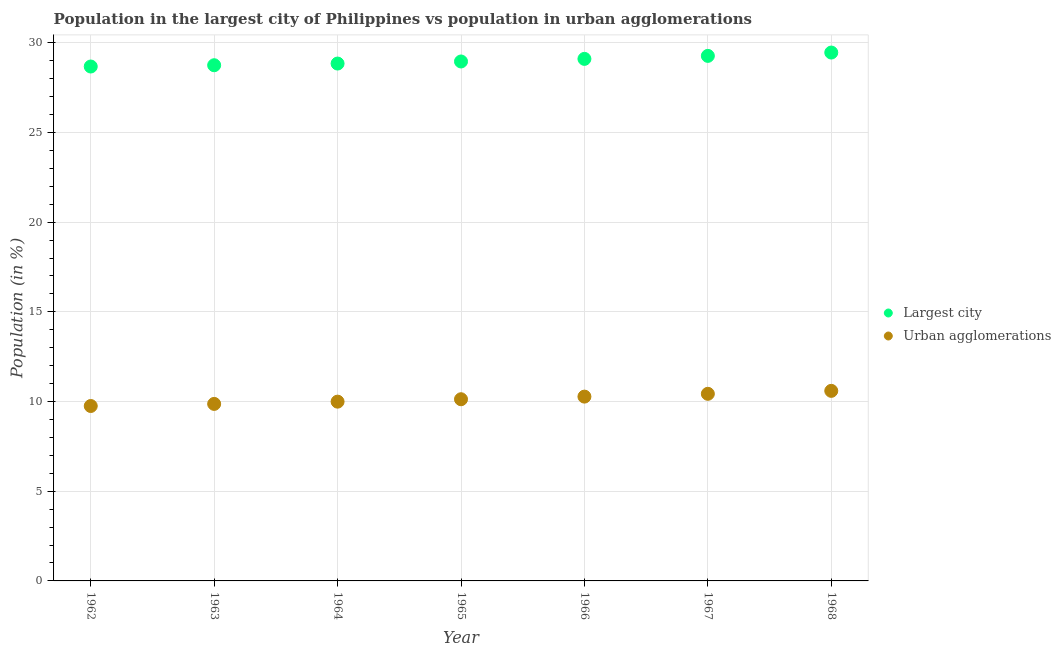How many different coloured dotlines are there?
Make the answer very short. 2. Is the number of dotlines equal to the number of legend labels?
Provide a short and direct response. Yes. What is the population in urban agglomerations in 1967?
Give a very brief answer. 10.43. Across all years, what is the maximum population in the largest city?
Give a very brief answer. 29.45. Across all years, what is the minimum population in the largest city?
Provide a short and direct response. 28.67. In which year was the population in the largest city maximum?
Ensure brevity in your answer.  1968. What is the total population in the largest city in the graph?
Provide a short and direct response. 203.03. What is the difference between the population in urban agglomerations in 1962 and that in 1968?
Offer a terse response. -0.84. What is the difference between the population in the largest city in 1966 and the population in urban agglomerations in 1963?
Provide a short and direct response. 19.23. What is the average population in urban agglomerations per year?
Ensure brevity in your answer.  10.15. In the year 1964, what is the difference between the population in urban agglomerations and population in the largest city?
Ensure brevity in your answer.  -18.85. What is the ratio of the population in urban agglomerations in 1964 to that in 1967?
Give a very brief answer. 0.96. Is the population in the largest city in 1965 less than that in 1967?
Keep it short and to the point. Yes. Is the difference between the population in the largest city in 1965 and 1967 greater than the difference between the population in urban agglomerations in 1965 and 1967?
Your response must be concise. No. What is the difference between the highest and the second highest population in urban agglomerations?
Provide a succinct answer. 0.16. What is the difference between the highest and the lowest population in the largest city?
Your answer should be very brief. 0.78. Does the population in the largest city monotonically increase over the years?
Make the answer very short. Yes. Is the population in urban agglomerations strictly greater than the population in the largest city over the years?
Offer a very short reply. No. Is the population in urban agglomerations strictly less than the population in the largest city over the years?
Provide a short and direct response. Yes. How many dotlines are there?
Provide a succinct answer. 2. How many years are there in the graph?
Ensure brevity in your answer.  7. Are the values on the major ticks of Y-axis written in scientific E-notation?
Your response must be concise. No. Where does the legend appear in the graph?
Your answer should be very brief. Center right. How many legend labels are there?
Offer a terse response. 2. How are the legend labels stacked?
Make the answer very short. Vertical. What is the title of the graph?
Offer a very short reply. Population in the largest city of Philippines vs population in urban agglomerations. What is the label or title of the X-axis?
Offer a terse response. Year. What is the label or title of the Y-axis?
Ensure brevity in your answer.  Population (in %). What is the Population (in %) of Largest city in 1962?
Offer a very short reply. 28.67. What is the Population (in %) in Urban agglomerations in 1962?
Your response must be concise. 9.75. What is the Population (in %) in Largest city in 1963?
Provide a succinct answer. 28.75. What is the Population (in %) in Urban agglomerations in 1963?
Make the answer very short. 9.87. What is the Population (in %) in Largest city in 1964?
Keep it short and to the point. 28.84. What is the Population (in %) in Urban agglomerations in 1964?
Your answer should be compact. 9.99. What is the Population (in %) in Largest city in 1965?
Your answer should be very brief. 28.95. What is the Population (in %) in Urban agglomerations in 1965?
Your response must be concise. 10.13. What is the Population (in %) in Largest city in 1966?
Provide a short and direct response. 29.1. What is the Population (in %) in Urban agglomerations in 1966?
Your response must be concise. 10.27. What is the Population (in %) of Largest city in 1967?
Give a very brief answer. 29.27. What is the Population (in %) in Urban agglomerations in 1967?
Make the answer very short. 10.43. What is the Population (in %) of Largest city in 1968?
Make the answer very short. 29.45. What is the Population (in %) in Urban agglomerations in 1968?
Keep it short and to the point. 10.59. Across all years, what is the maximum Population (in %) in Largest city?
Offer a very short reply. 29.45. Across all years, what is the maximum Population (in %) of Urban agglomerations?
Provide a short and direct response. 10.59. Across all years, what is the minimum Population (in %) of Largest city?
Offer a very short reply. 28.67. Across all years, what is the minimum Population (in %) of Urban agglomerations?
Your response must be concise. 9.75. What is the total Population (in %) of Largest city in the graph?
Offer a very short reply. 203.03. What is the total Population (in %) of Urban agglomerations in the graph?
Give a very brief answer. 71.03. What is the difference between the Population (in %) of Largest city in 1962 and that in 1963?
Your answer should be compact. -0.07. What is the difference between the Population (in %) of Urban agglomerations in 1962 and that in 1963?
Provide a short and direct response. -0.12. What is the difference between the Population (in %) in Largest city in 1962 and that in 1964?
Your answer should be compact. -0.17. What is the difference between the Population (in %) of Urban agglomerations in 1962 and that in 1964?
Offer a terse response. -0.24. What is the difference between the Population (in %) in Largest city in 1962 and that in 1965?
Provide a succinct answer. -0.28. What is the difference between the Population (in %) in Urban agglomerations in 1962 and that in 1965?
Give a very brief answer. -0.38. What is the difference between the Population (in %) in Largest city in 1962 and that in 1966?
Make the answer very short. -0.43. What is the difference between the Population (in %) in Urban agglomerations in 1962 and that in 1966?
Provide a short and direct response. -0.52. What is the difference between the Population (in %) in Largest city in 1962 and that in 1967?
Offer a terse response. -0.59. What is the difference between the Population (in %) of Urban agglomerations in 1962 and that in 1967?
Provide a short and direct response. -0.68. What is the difference between the Population (in %) in Largest city in 1962 and that in 1968?
Offer a very short reply. -0.78. What is the difference between the Population (in %) in Urban agglomerations in 1962 and that in 1968?
Ensure brevity in your answer.  -0.84. What is the difference between the Population (in %) in Largest city in 1963 and that in 1964?
Provide a short and direct response. -0.09. What is the difference between the Population (in %) of Urban agglomerations in 1963 and that in 1964?
Keep it short and to the point. -0.13. What is the difference between the Population (in %) of Largest city in 1963 and that in 1965?
Your answer should be compact. -0.21. What is the difference between the Population (in %) of Urban agglomerations in 1963 and that in 1965?
Your answer should be very brief. -0.26. What is the difference between the Population (in %) of Largest city in 1963 and that in 1966?
Make the answer very short. -0.35. What is the difference between the Population (in %) in Urban agglomerations in 1963 and that in 1966?
Ensure brevity in your answer.  -0.41. What is the difference between the Population (in %) in Largest city in 1963 and that in 1967?
Your answer should be very brief. -0.52. What is the difference between the Population (in %) of Urban agglomerations in 1963 and that in 1967?
Your response must be concise. -0.56. What is the difference between the Population (in %) of Largest city in 1963 and that in 1968?
Your answer should be compact. -0.71. What is the difference between the Population (in %) of Urban agglomerations in 1963 and that in 1968?
Your answer should be very brief. -0.73. What is the difference between the Population (in %) in Largest city in 1964 and that in 1965?
Offer a terse response. -0.12. What is the difference between the Population (in %) in Urban agglomerations in 1964 and that in 1965?
Keep it short and to the point. -0.13. What is the difference between the Population (in %) in Largest city in 1964 and that in 1966?
Keep it short and to the point. -0.26. What is the difference between the Population (in %) in Urban agglomerations in 1964 and that in 1966?
Make the answer very short. -0.28. What is the difference between the Population (in %) in Largest city in 1964 and that in 1967?
Keep it short and to the point. -0.43. What is the difference between the Population (in %) in Urban agglomerations in 1964 and that in 1967?
Your response must be concise. -0.44. What is the difference between the Population (in %) of Largest city in 1964 and that in 1968?
Give a very brief answer. -0.61. What is the difference between the Population (in %) of Urban agglomerations in 1964 and that in 1968?
Keep it short and to the point. -0.6. What is the difference between the Population (in %) in Largest city in 1965 and that in 1966?
Keep it short and to the point. -0.14. What is the difference between the Population (in %) of Urban agglomerations in 1965 and that in 1966?
Offer a terse response. -0.15. What is the difference between the Population (in %) in Largest city in 1965 and that in 1967?
Provide a short and direct response. -0.31. What is the difference between the Population (in %) in Urban agglomerations in 1965 and that in 1967?
Provide a short and direct response. -0.3. What is the difference between the Population (in %) of Largest city in 1965 and that in 1968?
Offer a terse response. -0.5. What is the difference between the Population (in %) in Urban agglomerations in 1965 and that in 1968?
Make the answer very short. -0.47. What is the difference between the Population (in %) of Largest city in 1966 and that in 1967?
Your answer should be very brief. -0.17. What is the difference between the Population (in %) of Urban agglomerations in 1966 and that in 1967?
Provide a short and direct response. -0.16. What is the difference between the Population (in %) in Largest city in 1966 and that in 1968?
Make the answer very short. -0.35. What is the difference between the Population (in %) in Urban agglomerations in 1966 and that in 1968?
Ensure brevity in your answer.  -0.32. What is the difference between the Population (in %) in Largest city in 1967 and that in 1968?
Provide a succinct answer. -0.19. What is the difference between the Population (in %) of Urban agglomerations in 1967 and that in 1968?
Your response must be concise. -0.16. What is the difference between the Population (in %) in Largest city in 1962 and the Population (in %) in Urban agglomerations in 1963?
Make the answer very short. 18.81. What is the difference between the Population (in %) of Largest city in 1962 and the Population (in %) of Urban agglomerations in 1964?
Ensure brevity in your answer.  18.68. What is the difference between the Population (in %) in Largest city in 1962 and the Population (in %) in Urban agglomerations in 1965?
Offer a terse response. 18.55. What is the difference between the Population (in %) in Largest city in 1962 and the Population (in %) in Urban agglomerations in 1966?
Your response must be concise. 18.4. What is the difference between the Population (in %) in Largest city in 1962 and the Population (in %) in Urban agglomerations in 1967?
Provide a succinct answer. 18.24. What is the difference between the Population (in %) of Largest city in 1962 and the Population (in %) of Urban agglomerations in 1968?
Provide a succinct answer. 18.08. What is the difference between the Population (in %) of Largest city in 1963 and the Population (in %) of Urban agglomerations in 1964?
Your answer should be compact. 18.75. What is the difference between the Population (in %) of Largest city in 1963 and the Population (in %) of Urban agglomerations in 1965?
Provide a succinct answer. 18.62. What is the difference between the Population (in %) in Largest city in 1963 and the Population (in %) in Urban agglomerations in 1966?
Make the answer very short. 18.47. What is the difference between the Population (in %) in Largest city in 1963 and the Population (in %) in Urban agglomerations in 1967?
Give a very brief answer. 18.32. What is the difference between the Population (in %) in Largest city in 1963 and the Population (in %) in Urban agglomerations in 1968?
Provide a short and direct response. 18.15. What is the difference between the Population (in %) in Largest city in 1964 and the Population (in %) in Urban agglomerations in 1965?
Provide a succinct answer. 18.71. What is the difference between the Population (in %) of Largest city in 1964 and the Population (in %) of Urban agglomerations in 1966?
Keep it short and to the point. 18.57. What is the difference between the Population (in %) of Largest city in 1964 and the Population (in %) of Urban agglomerations in 1967?
Keep it short and to the point. 18.41. What is the difference between the Population (in %) of Largest city in 1964 and the Population (in %) of Urban agglomerations in 1968?
Your response must be concise. 18.24. What is the difference between the Population (in %) in Largest city in 1965 and the Population (in %) in Urban agglomerations in 1966?
Make the answer very short. 18.68. What is the difference between the Population (in %) of Largest city in 1965 and the Population (in %) of Urban agglomerations in 1967?
Offer a terse response. 18.52. What is the difference between the Population (in %) in Largest city in 1965 and the Population (in %) in Urban agglomerations in 1968?
Offer a terse response. 18.36. What is the difference between the Population (in %) of Largest city in 1966 and the Population (in %) of Urban agglomerations in 1967?
Offer a very short reply. 18.67. What is the difference between the Population (in %) in Largest city in 1966 and the Population (in %) in Urban agglomerations in 1968?
Provide a short and direct response. 18.5. What is the difference between the Population (in %) in Largest city in 1967 and the Population (in %) in Urban agglomerations in 1968?
Your response must be concise. 18.67. What is the average Population (in %) of Largest city per year?
Your response must be concise. 29. What is the average Population (in %) of Urban agglomerations per year?
Your answer should be very brief. 10.15. In the year 1962, what is the difference between the Population (in %) of Largest city and Population (in %) of Urban agglomerations?
Provide a succinct answer. 18.92. In the year 1963, what is the difference between the Population (in %) in Largest city and Population (in %) in Urban agglomerations?
Your response must be concise. 18.88. In the year 1964, what is the difference between the Population (in %) of Largest city and Population (in %) of Urban agglomerations?
Offer a terse response. 18.85. In the year 1965, what is the difference between the Population (in %) of Largest city and Population (in %) of Urban agglomerations?
Provide a short and direct response. 18.83. In the year 1966, what is the difference between the Population (in %) in Largest city and Population (in %) in Urban agglomerations?
Your answer should be very brief. 18.83. In the year 1967, what is the difference between the Population (in %) of Largest city and Population (in %) of Urban agglomerations?
Make the answer very short. 18.84. In the year 1968, what is the difference between the Population (in %) of Largest city and Population (in %) of Urban agglomerations?
Your answer should be compact. 18.86. What is the ratio of the Population (in %) of Largest city in 1962 to that in 1963?
Give a very brief answer. 1. What is the ratio of the Population (in %) of Urban agglomerations in 1962 to that in 1963?
Make the answer very short. 0.99. What is the ratio of the Population (in %) in Urban agglomerations in 1962 to that in 1964?
Ensure brevity in your answer.  0.98. What is the ratio of the Population (in %) in Largest city in 1962 to that in 1965?
Offer a terse response. 0.99. What is the ratio of the Population (in %) in Urban agglomerations in 1962 to that in 1965?
Give a very brief answer. 0.96. What is the ratio of the Population (in %) in Largest city in 1962 to that in 1966?
Your answer should be compact. 0.99. What is the ratio of the Population (in %) of Urban agglomerations in 1962 to that in 1966?
Offer a terse response. 0.95. What is the ratio of the Population (in %) in Largest city in 1962 to that in 1967?
Your answer should be very brief. 0.98. What is the ratio of the Population (in %) in Urban agglomerations in 1962 to that in 1967?
Your answer should be compact. 0.93. What is the ratio of the Population (in %) in Largest city in 1962 to that in 1968?
Your answer should be very brief. 0.97. What is the ratio of the Population (in %) of Urban agglomerations in 1962 to that in 1968?
Ensure brevity in your answer.  0.92. What is the ratio of the Population (in %) in Urban agglomerations in 1963 to that in 1964?
Give a very brief answer. 0.99. What is the ratio of the Population (in %) in Urban agglomerations in 1963 to that in 1965?
Keep it short and to the point. 0.97. What is the ratio of the Population (in %) in Largest city in 1963 to that in 1966?
Provide a short and direct response. 0.99. What is the ratio of the Population (in %) in Urban agglomerations in 1963 to that in 1966?
Your response must be concise. 0.96. What is the ratio of the Population (in %) in Largest city in 1963 to that in 1967?
Offer a terse response. 0.98. What is the ratio of the Population (in %) in Urban agglomerations in 1963 to that in 1967?
Your response must be concise. 0.95. What is the ratio of the Population (in %) in Urban agglomerations in 1963 to that in 1968?
Your response must be concise. 0.93. What is the ratio of the Population (in %) of Largest city in 1964 to that in 1965?
Keep it short and to the point. 1. What is the ratio of the Population (in %) of Urban agglomerations in 1964 to that in 1965?
Your answer should be very brief. 0.99. What is the ratio of the Population (in %) in Largest city in 1964 to that in 1966?
Keep it short and to the point. 0.99. What is the ratio of the Population (in %) of Urban agglomerations in 1964 to that in 1966?
Your response must be concise. 0.97. What is the ratio of the Population (in %) of Largest city in 1964 to that in 1967?
Give a very brief answer. 0.99. What is the ratio of the Population (in %) in Urban agglomerations in 1964 to that in 1967?
Offer a very short reply. 0.96. What is the ratio of the Population (in %) in Largest city in 1964 to that in 1968?
Offer a very short reply. 0.98. What is the ratio of the Population (in %) of Urban agglomerations in 1964 to that in 1968?
Offer a very short reply. 0.94. What is the ratio of the Population (in %) of Largest city in 1965 to that in 1966?
Offer a terse response. 0.99. What is the ratio of the Population (in %) in Urban agglomerations in 1965 to that in 1966?
Your response must be concise. 0.99. What is the ratio of the Population (in %) in Largest city in 1965 to that in 1967?
Ensure brevity in your answer.  0.99. What is the ratio of the Population (in %) in Largest city in 1965 to that in 1968?
Your response must be concise. 0.98. What is the ratio of the Population (in %) in Urban agglomerations in 1965 to that in 1968?
Provide a short and direct response. 0.96. What is the ratio of the Population (in %) in Largest city in 1966 to that in 1967?
Offer a terse response. 0.99. What is the ratio of the Population (in %) in Urban agglomerations in 1966 to that in 1967?
Give a very brief answer. 0.98. What is the ratio of the Population (in %) in Urban agglomerations in 1966 to that in 1968?
Give a very brief answer. 0.97. What is the ratio of the Population (in %) in Urban agglomerations in 1967 to that in 1968?
Keep it short and to the point. 0.98. What is the difference between the highest and the second highest Population (in %) in Largest city?
Offer a very short reply. 0.19. What is the difference between the highest and the second highest Population (in %) of Urban agglomerations?
Your response must be concise. 0.16. What is the difference between the highest and the lowest Population (in %) in Largest city?
Provide a short and direct response. 0.78. What is the difference between the highest and the lowest Population (in %) of Urban agglomerations?
Your response must be concise. 0.84. 